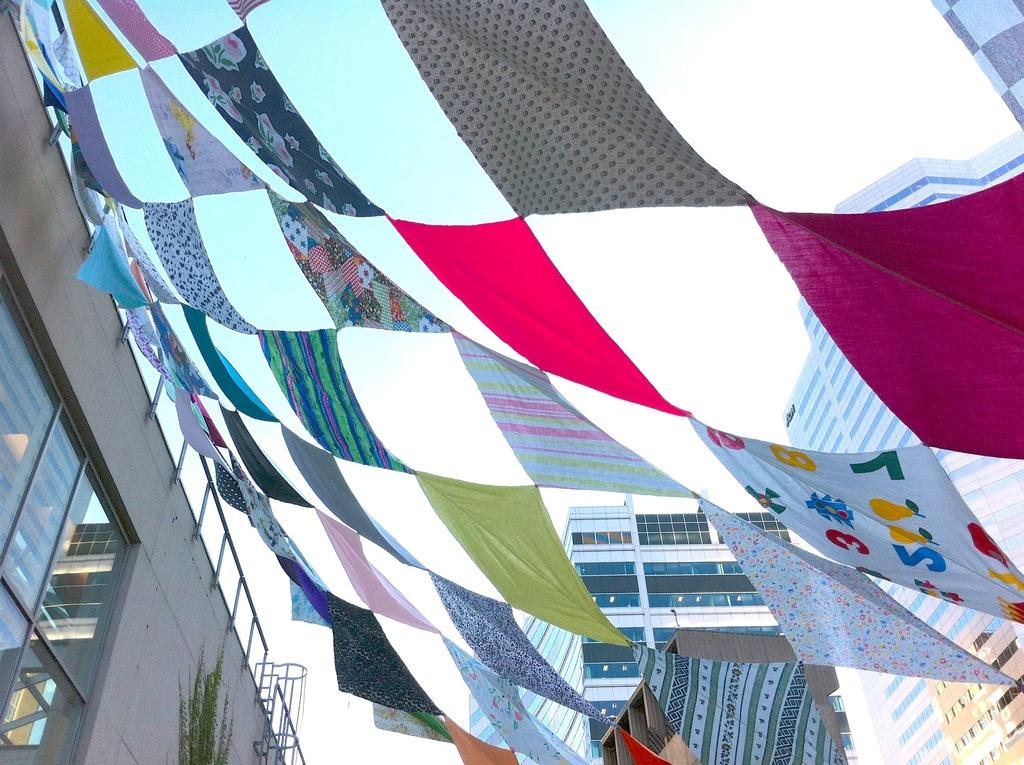What structure is located on the left side of the image? There is a building on the left side of the image. What is attached to the fence of the building? Clothes are attached to the fence of the building. What is visible in the middle of the image? The sky is visible in the middle of the image. How many geese are flying in the committee meeting in the image? There are no geese or committee meetings present in the image. 